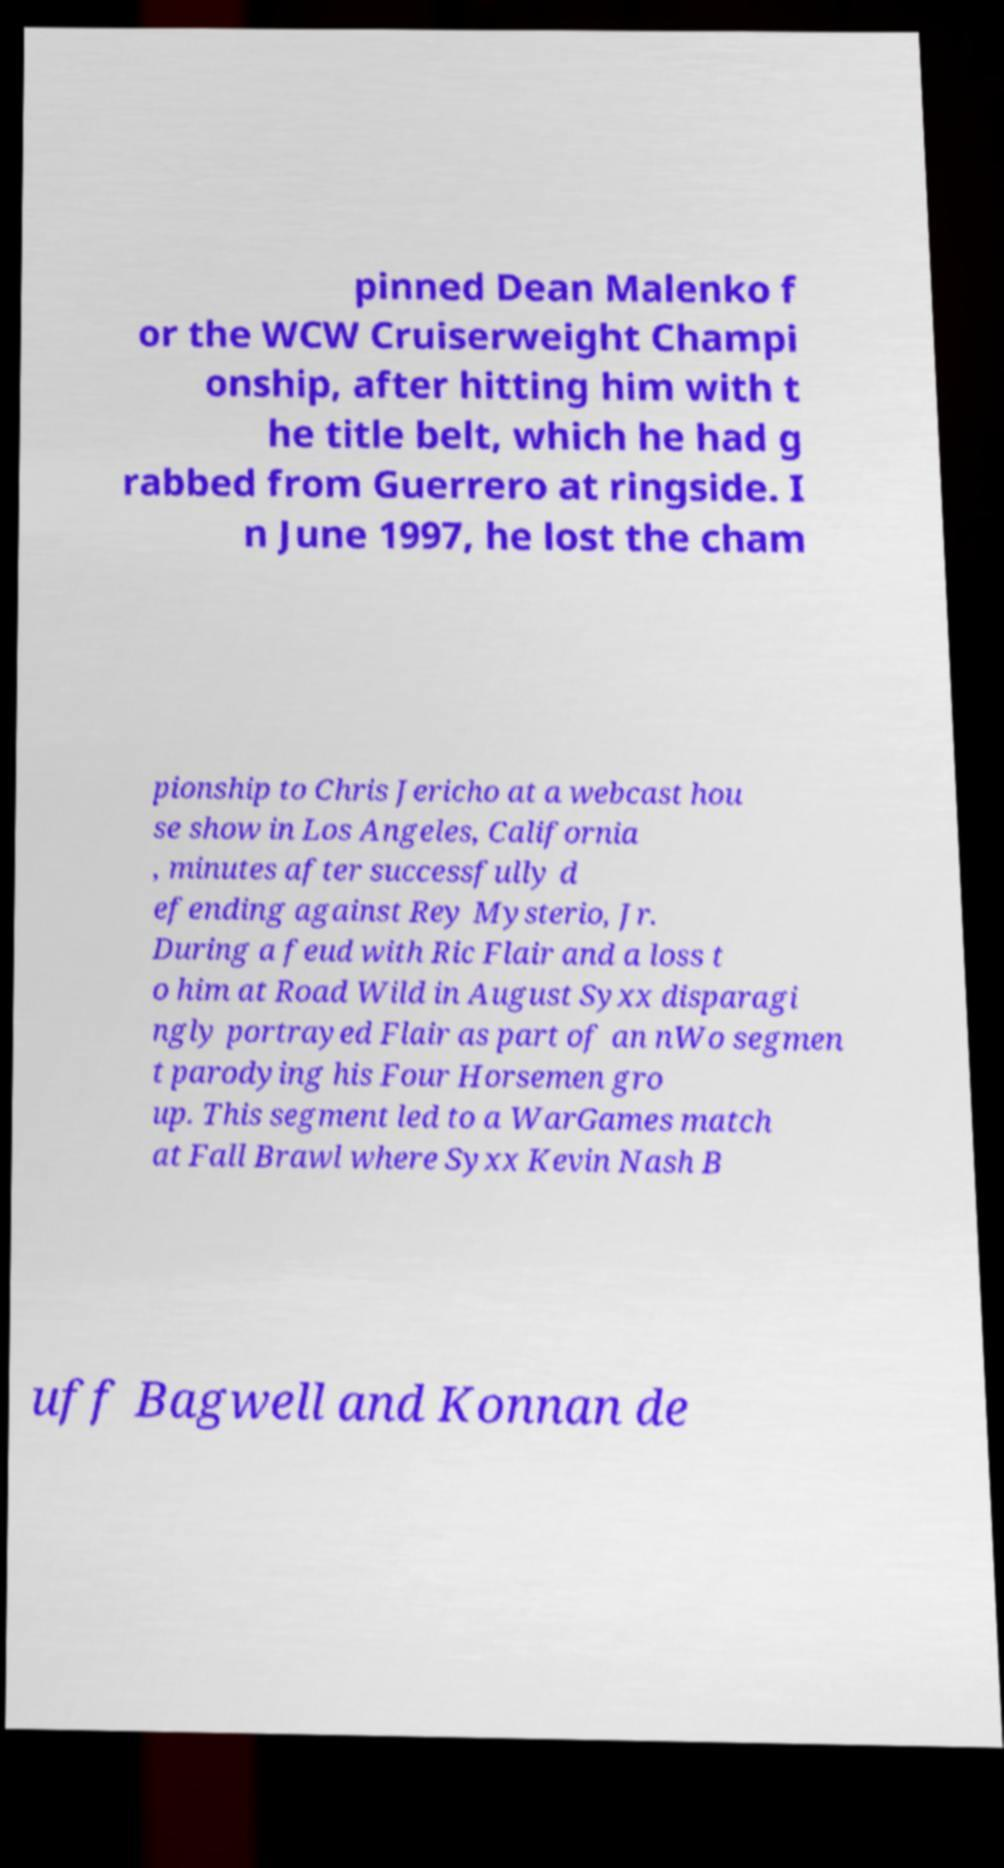For documentation purposes, I need the text within this image transcribed. Could you provide that? pinned Dean Malenko f or the WCW Cruiserweight Champi onship, after hitting him with t he title belt, which he had g rabbed from Guerrero at ringside. I n June 1997, he lost the cham pionship to Chris Jericho at a webcast hou se show in Los Angeles, California , minutes after successfully d efending against Rey Mysterio, Jr. During a feud with Ric Flair and a loss t o him at Road Wild in August Syxx disparagi ngly portrayed Flair as part of an nWo segmen t parodying his Four Horsemen gro up. This segment led to a WarGames match at Fall Brawl where Syxx Kevin Nash B uff Bagwell and Konnan de 